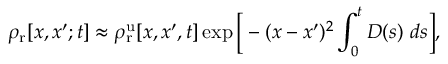<formula> <loc_0><loc_0><loc_500><loc_500>\rho _ { r } [ x , x ^ { \prime } ; t ] \approx \rho _ { r } ^ { u } [ x , x ^ { \prime } , t ] \exp { \left [ - ( x - x ^ { \prime } ) ^ { 2 } \int _ { 0 } ^ { t } D ( s ) d s \right ] } ,</formula> 